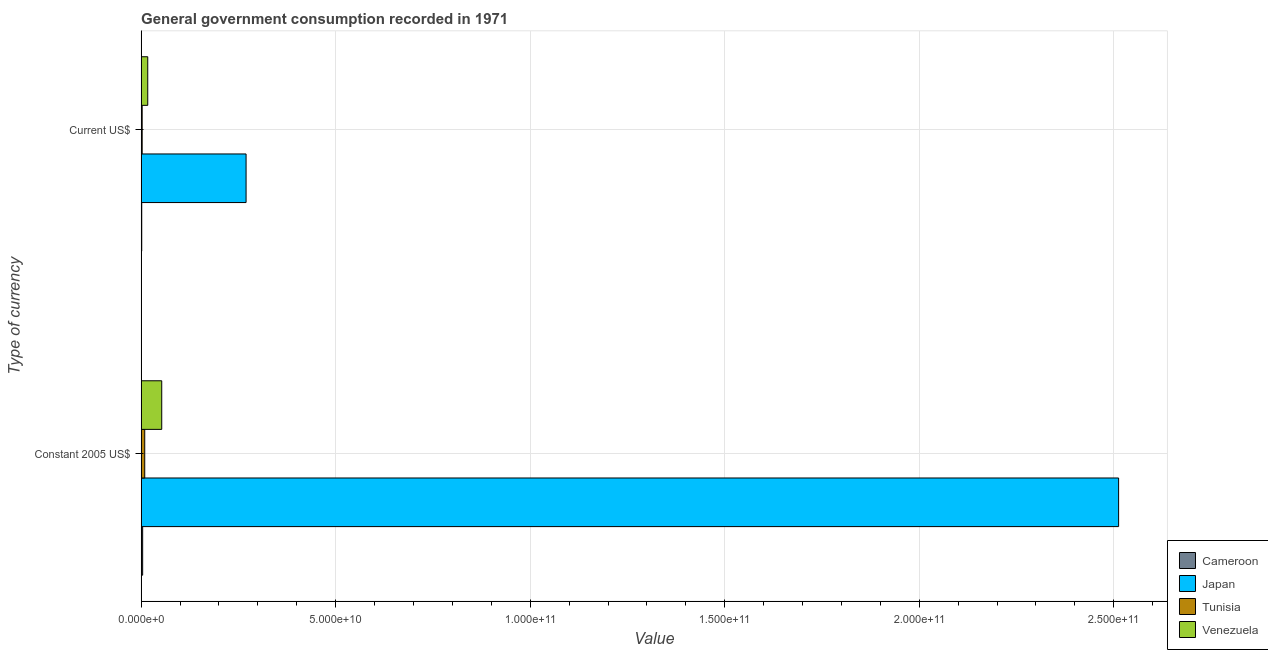How many different coloured bars are there?
Your response must be concise. 4. Are the number of bars per tick equal to the number of legend labels?
Keep it short and to the point. Yes. How many bars are there on the 2nd tick from the top?
Provide a succinct answer. 4. How many bars are there on the 2nd tick from the bottom?
Ensure brevity in your answer.  4. What is the label of the 1st group of bars from the top?
Offer a very short reply. Current US$. What is the value consumed in constant 2005 us$ in Tunisia?
Give a very brief answer. 9.24e+08. Across all countries, what is the maximum value consumed in constant 2005 us$?
Make the answer very short. 2.51e+11. Across all countries, what is the minimum value consumed in current us$?
Ensure brevity in your answer.  1.50e+08. In which country was the value consumed in constant 2005 us$ maximum?
Your response must be concise. Japan. In which country was the value consumed in current us$ minimum?
Give a very brief answer. Cameroon. What is the total value consumed in current us$ in the graph?
Provide a short and direct response. 2.91e+1. What is the difference between the value consumed in current us$ in Venezuela and that in Tunisia?
Offer a terse response. 1.43e+09. What is the difference between the value consumed in current us$ in Venezuela and the value consumed in constant 2005 us$ in Japan?
Make the answer very short. -2.50e+11. What is the average value consumed in constant 2005 us$ per country?
Offer a terse response. 6.45e+1. What is the difference between the value consumed in current us$ and value consumed in constant 2005 us$ in Cameroon?
Make the answer very short. -2.37e+08. What is the ratio of the value consumed in current us$ in Venezuela to that in Japan?
Offer a very short reply. 0.06. Is the value consumed in current us$ in Venezuela less than that in Tunisia?
Your answer should be compact. No. What does the 3rd bar from the bottom in Constant 2005 US$ represents?
Offer a very short reply. Tunisia. How many bars are there?
Make the answer very short. 8. Are all the bars in the graph horizontal?
Your answer should be very brief. Yes. Where does the legend appear in the graph?
Your response must be concise. Bottom right. How many legend labels are there?
Offer a terse response. 4. What is the title of the graph?
Ensure brevity in your answer.  General government consumption recorded in 1971. Does "Bulgaria" appear as one of the legend labels in the graph?
Offer a terse response. No. What is the label or title of the X-axis?
Give a very brief answer. Value. What is the label or title of the Y-axis?
Provide a succinct answer. Type of currency. What is the Value in Cameroon in Constant 2005 US$?
Keep it short and to the point. 3.87e+08. What is the Value of Japan in Constant 2005 US$?
Your answer should be very brief. 2.51e+11. What is the Value in Tunisia in Constant 2005 US$?
Your answer should be very brief. 9.24e+08. What is the Value in Venezuela in Constant 2005 US$?
Your response must be concise. 5.29e+09. What is the Value in Cameroon in Current US$?
Your answer should be compact. 1.50e+08. What is the Value in Japan in Current US$?
Your answer should be very brief. 2.70e+1. What is the Value of Tunisia in Current US$?
Offer a very short reply. 2.64e+08. What is the Value in Venezuela in Current US$?
Provide a short and direct response. 1.70e+09. Across all Type of currency, what is the maximum Value in Cameroon?
Offer a very short reply. 3.87e+08. Across all Type of currency, what is the maximum Value of Japan?
Offer a terse response. 2.51e+11. Across all Type of currency, what is the maximum Value of Tunisia?
Your response must be concise. 9.24e+08. Across all Type of currency, what is the maximum Value in Venezuela?
Ensure brevity in your answer.  5.29e+09. Across all Type of currency, what is the minimum Value in Cameroon?
Give a very brief answer. 1.50e+08. Across all Type of currency, what is the minimum Value of Japan?
Offer a very short reply. 2.70e+1. Across all Type of currency, what is the minimum Value of Tunisia?
Offer a terse response. 2.64e+08. Across all Type of currency, what is the minimum Value of Venezuela?
Give a very brief answer. 1.70e+09. What is the total Value of Cameroon in the graph?
Offer a terse response. 5.38e+08. What is the total Value of Japan in the graph?
Give a very brief answer. 2.78e+11. What is the total Value in Tunisia in the graph?
Make the answer very short. 1.19e+09. What is the total Value of Venezuela in the graph?
Your answer should be compact. 6.99e+09. What is the difference between the Value in Cameroon in Constant 2005 US$ and that in Current US$?
Offer a terse response. 2.37e+08. What is the difference between the Value of Japan in Constant 2005 US$ and that in Current US$?
Give a very brief answer. 2.24e+11. What is the difference between the Value in Tunisia in Constant 2005 US$ and that in Current US$?
Your answer should be compact. 6.60e+08. What is the difference between the Value in Venezuela in Constant 2005 US$ and that in Current US$?
Give a very brief answer. 3.60e+09. What is the difference between the Value of Cameroon in Constant 2005 US$ and the Value of Japan in Current US$?
Your answer should be very brief. -2.66e+1. What is the difference between the Value in Cameroon in Constant 2005 US$ and the Value in Tunisia in Current US$?
Provide a succinct answer. 1.23e+08. What is the difference between the Value in Cameroon in Constant 2005 US$ and the Value in Venezuela in Current US$?
Provide a succinct answer. -1.31e+09. What is the difference between the Value in Japan in Constant 2005 US$ and the Value in Tunisia in Current US$?
Give a very brief answer. 2.51e+11. What is the difference between the Value of Japan in Constant 2005 US$ and the Value of Venezuela in Current US$?
Your answer should be compact. 2.50e+11. What is the difference between the Value of Tunisia in Constant 2005 US$ and the Value of Venezuela in Current US$?
Give a very brief answer. -7.74e+08. What is the average Value in Cameroon per Type of currency?
Your answer should be very brief. 2.69e+08. What is the average Value of Japan per Type of currency?
Make the answer very short. 1.39e+11. What is the average Value in Tunisia per Type of currency?
Provide a succinct answer. 5.94e+08. What is the average Value of Venezuela per Type of currency?
Offer a very short reply. 3.49e+09. What is the difference between the Value in Cameroon and Value in Japan in Constant 2005 US$?
Keep it short and to the point. -2.51e+11. What is the difference between the Value of Cameroon and Value of Tunisia in Constant 2005 US$?
Your answer should be compact. -5.37e+08. What is the difference between the Value of Cameroon and Value of Venezuela in Constant 2005 US$?
Make the answer very short. -4.91e+09. What is the difference between the Value in Japan and Value in Tunisia in Constant 2005 US$?
Ensure brevity in your answer.  2.50e+11. What is the difference between the Value in Japan and Value in Venezuela in Constant 2005 US$?
Provide a short and direct response. 2.46e+11. What is the difference between the Value in Tunisia and Value in Venezuela in Constant 2005 US$?
Give a very brief answer. -4.37e+09. What is the difference between the Value in Cameroon and Value in Japan in Current US$?
Offer a terse response. -2.68e+1. What is the difference between the Value of Cameroon and Value of Tunisia in Current US$?
Keep it short and to the point. -1.14e+08. What is the difference between the Value in Cameroon and Value in Venezuela in Current US$?
Offer a very short reply. -1.55e+09. What is the difference between the Value in Japan and Value in Tunisia in Current US$?
Your response must be concise. 2.67e+1. What is the difference between the Value in Japan and Value in Venezuela in Current US$?
Provide a succinct answer. 2.53e+1. What is the difference between the Value of Tunisia and Value of Venezuela in Current US$?
Give a very brief answer. -1.43e+09. What is the ratio of the Value in Cameroon in Constant 2005 US$ to that in Current US$?
Provide a short and direct response. 2.58. What is the ratio of the Value in Japan in Constant 2005 US$ to that in Current US$?
Offer a very short reply. 9.32. What is the ratio of the Value in Tunisia in Constant 2005 US$ to that in Current US$?
Offer a very short reply. 3.5. What is the ratio of the Value in Venezuela in Constant 2005 US$ to that in Current US$?
Ensure brevity in your answer.  3.12. What is the difference between the highest and the second highest Value of Cameroon?
Keep it short and to the point. 2.37e+08. What is the difference between the highest and the second highest Value of Japan?
Ensure brevity in your answer.  2.24e+11. What is the difference between the highest and the second highest Value of Tunisia?
Provide a short and direct response. 6.60e+08. What is the difference between the highest and the second highest Value of Venezuela?
Offer a very short reply. 3.60e+09. What is the difference between the highest and the lowest Value in Cameroon?
Provide a short and direct response. 2.37e+08. What is the difference between the highest and the lowest Value of Japan?
Offer a terse response. 2.24e+11. What is the difference between the highest and the lowest Value in Tunisia?
Your answer should be very brief. 6.60e+08. What is the difference between the highest and the lowest Value in Venezuela?
Your answer should be very brief. 3.60e+09. 